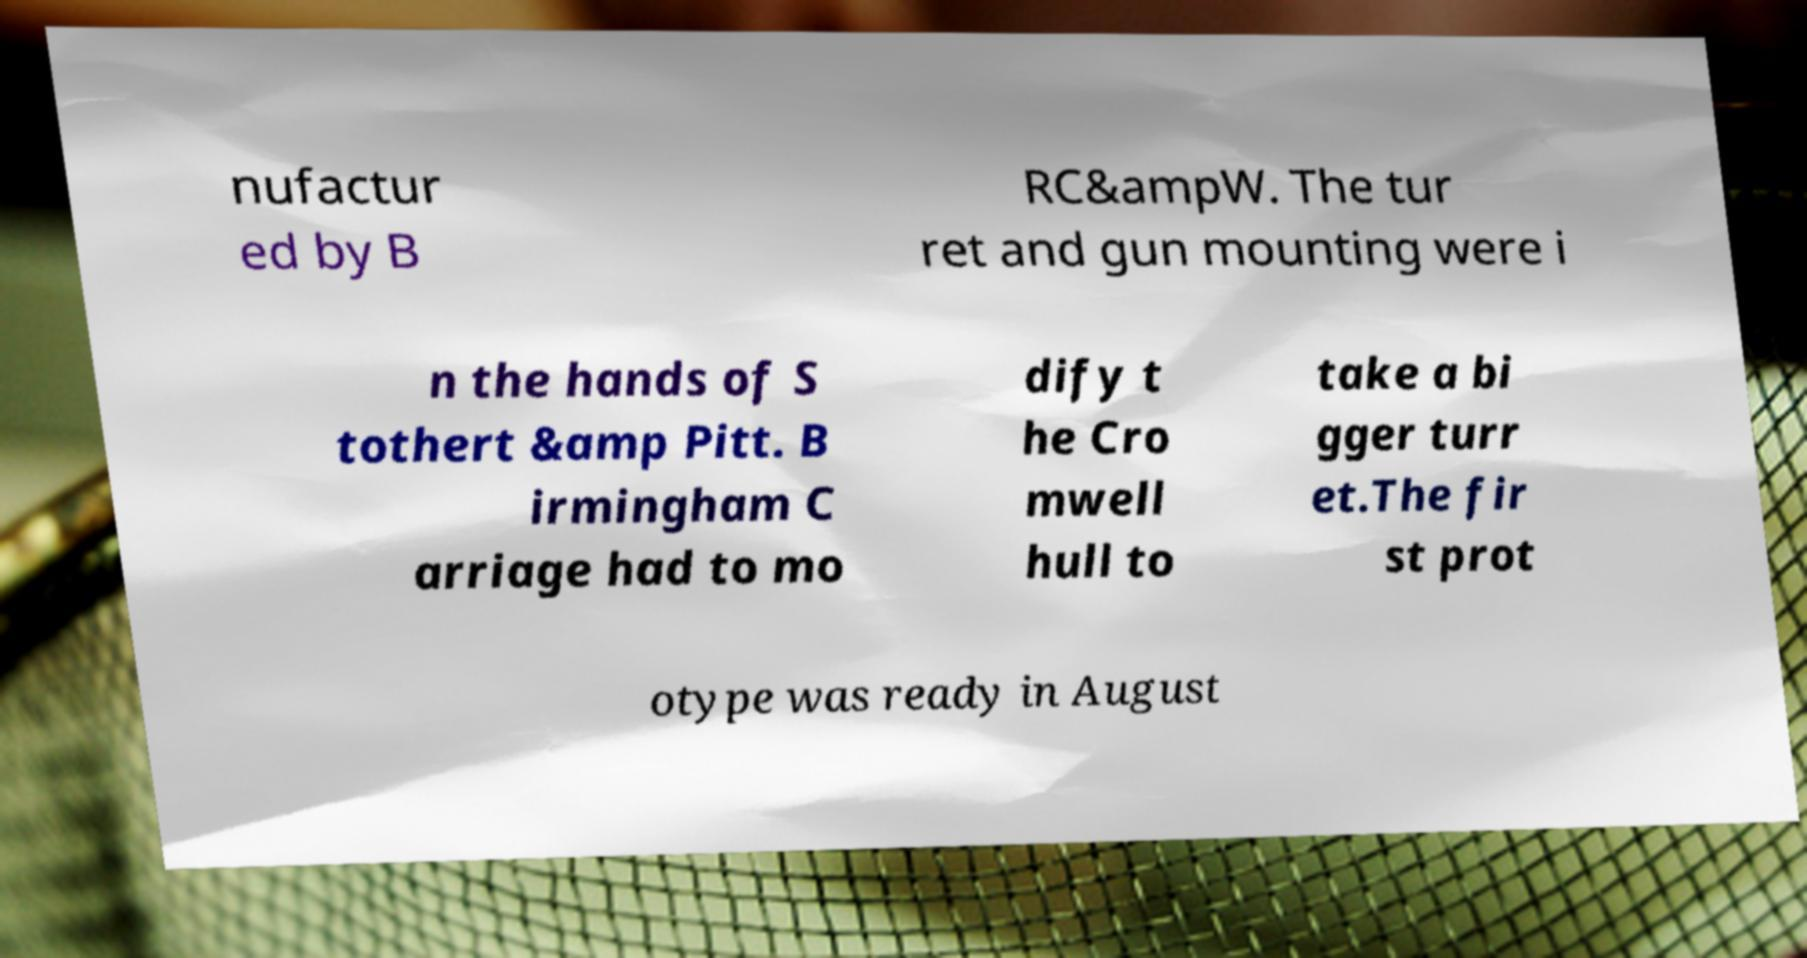Please read and relay the text visible in this image. What does it say? nufactur ed by B RC&ampW. The tur ret and gun mounting were i n the hands of S tothert &amp Pitt. B irmingham C arriage had to mo dify t he Cro mwell hull to take a bi gger turr et.The fir st prot otype was ready in August 